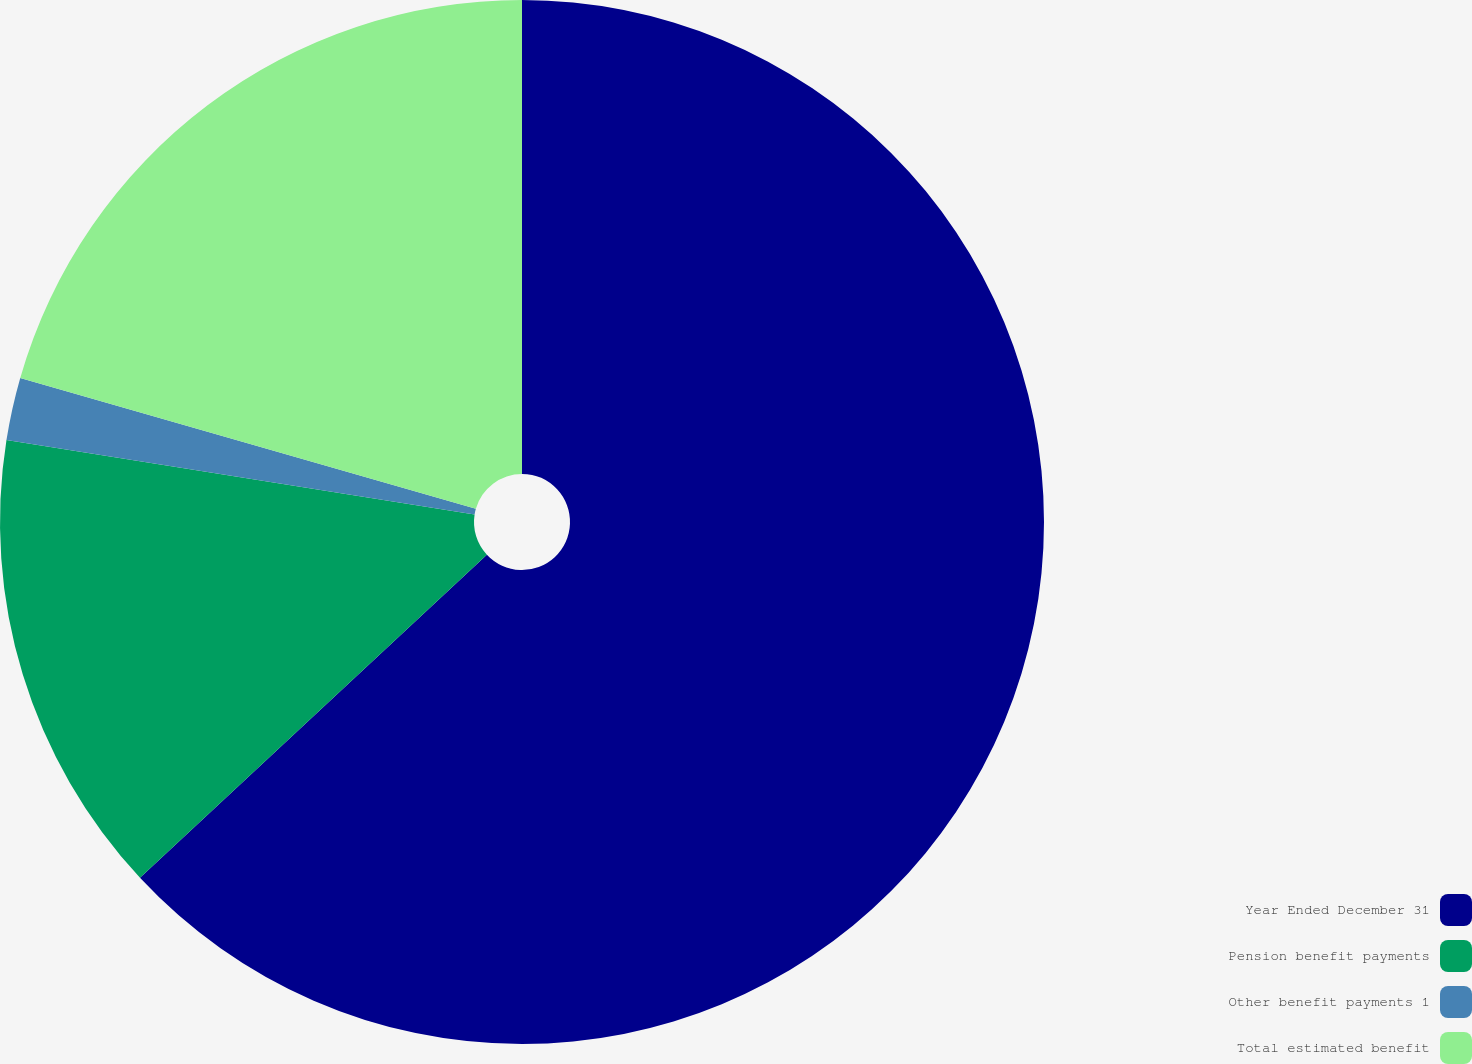<chart> <loc_0><loc_0><loc_500><loc_500><pie_chart><fcel>Year Ended December 31<fcel>Pension benefit payments<fcel>Other benefit payments 1<fcel>Total estimated benefit<nl><fcel>63.06%<fcel>14.44%<fcel>1.94%<fcel>20.55%<nl></chart> 